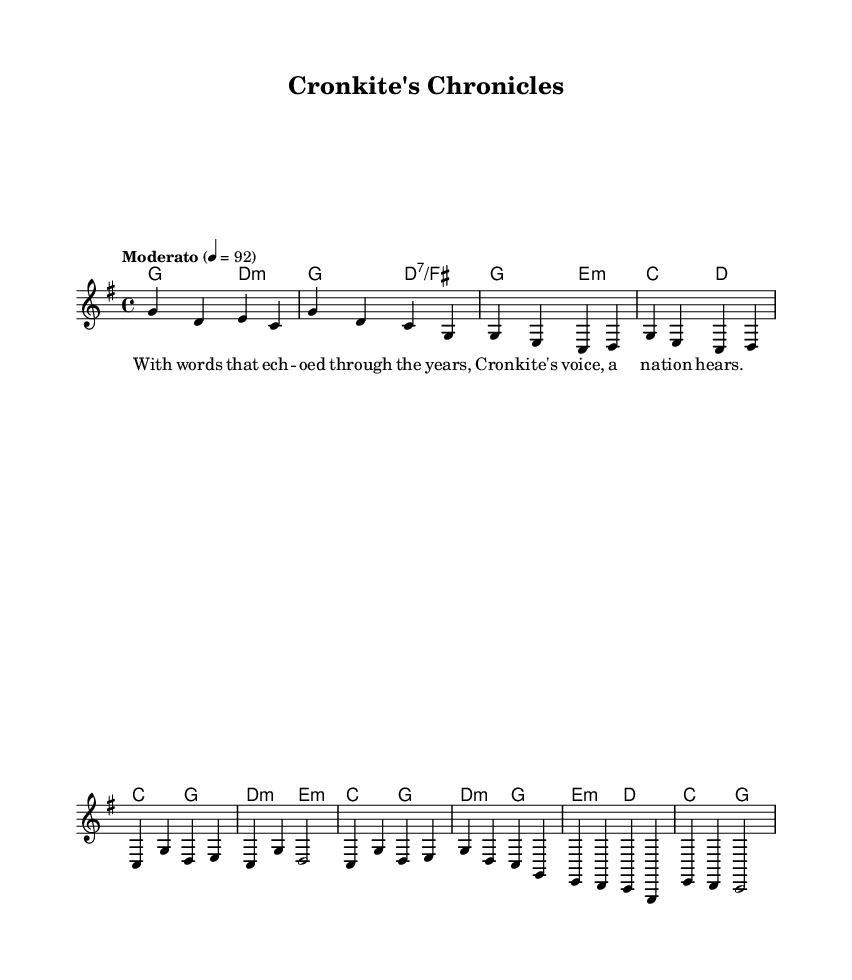What is the key signature of this music? The key signature is G major, which has one sharp (F#). This can be identified at the beginning of the score where the key signature is indicated.
Answer: G major What is the time signature of this music? The time signature is 4/4, which is displayed at the beginning of the score. This indicates that there are four beats in each measure and a quarter note receives one beat.
Answer: 4/4 What is the tempo marking for this piece? The tempo marking is "Moderato", which usually indicates a moderate pace. It is specified in the musical directions at the start of the score.
Answer: Moderato How many bars are in the chorus section? The chorus section consists of 4 bars, which can be determined by counting the measures labeled in that part of the sheet music. Each measure is separated by a vertical line.
Answer: 4 Which chords are used in the bridge section? The bridge section includes the chords E minor, D major, and C major, which can be identified in the harmony lines associated with that part of the melody.
Answer: E minor, D major, C major What theme does this music suggest in its lyrics? The lyrics portray a narrative about the life and impact of Cronkite as a journalist, emphasizing his voice and influence on a nation. This can be inferred from the words provided in the verse.
Answer: Cronkite's influence 